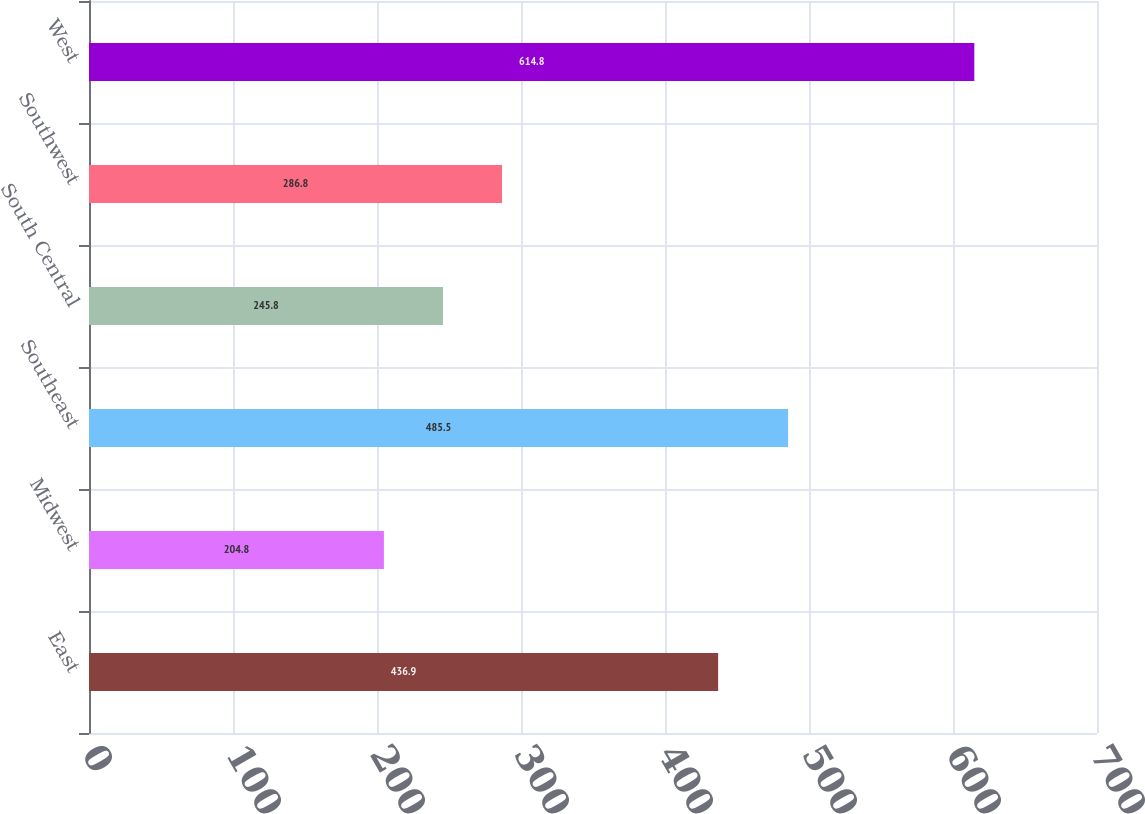<chart> <loc_0><loc_0><loc_500><loc_500><bar_chart><fcel>East<fcel>Midwest<fcel>Southeast<fcel>South Central<fcel>Southwest<fcel>West<nl><fcel>436.9<fcel>204.8<fcel>485.5<fcel>245.8<fcel>286.8<fcel>614.8<nl></chart> 